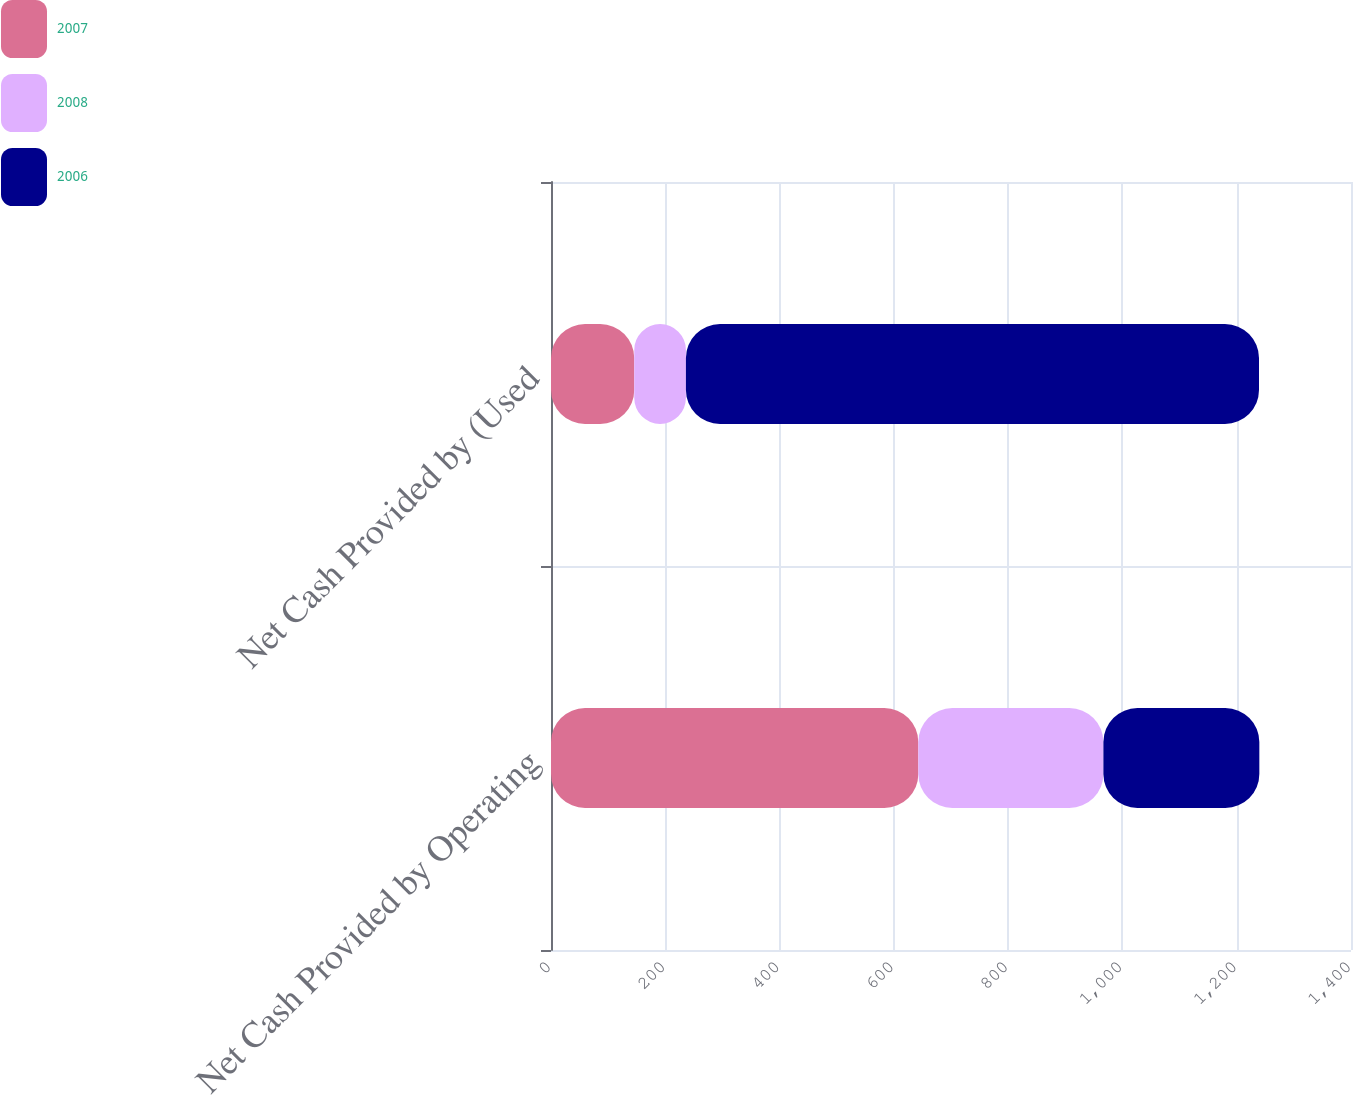Convert chart. <chart><loc_0><loc_0><loc_500><loc_500><stacked_bar_chart><ecel><fcel>Net Cash Provided by Operating<fcel>Net Cash Provided by (Used<nl><fcel>2007<fcel>642.8<fcel>145.7<nl><fcel>2008<fcel>323.9<fcel>90.4<nl><fcel>2006<fcel>272.9<fcel>1002.9<nl></chart> 